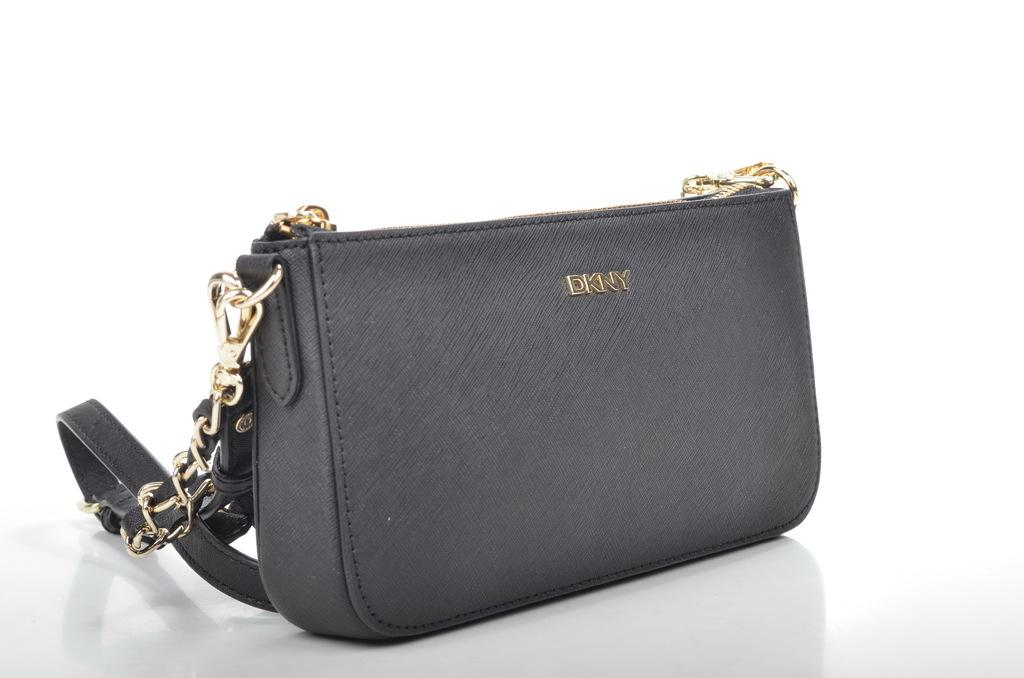What type of accessory is visible in the image? There is a handbag in the image. What color is the handbag? The handbag is grey in color. What type of handles does the handbag have? The handbag has golden chain handles. What type of food is being taught in the image? There is no food or teaching activity present in the image; it features a grey handbag with golden chain handles. 